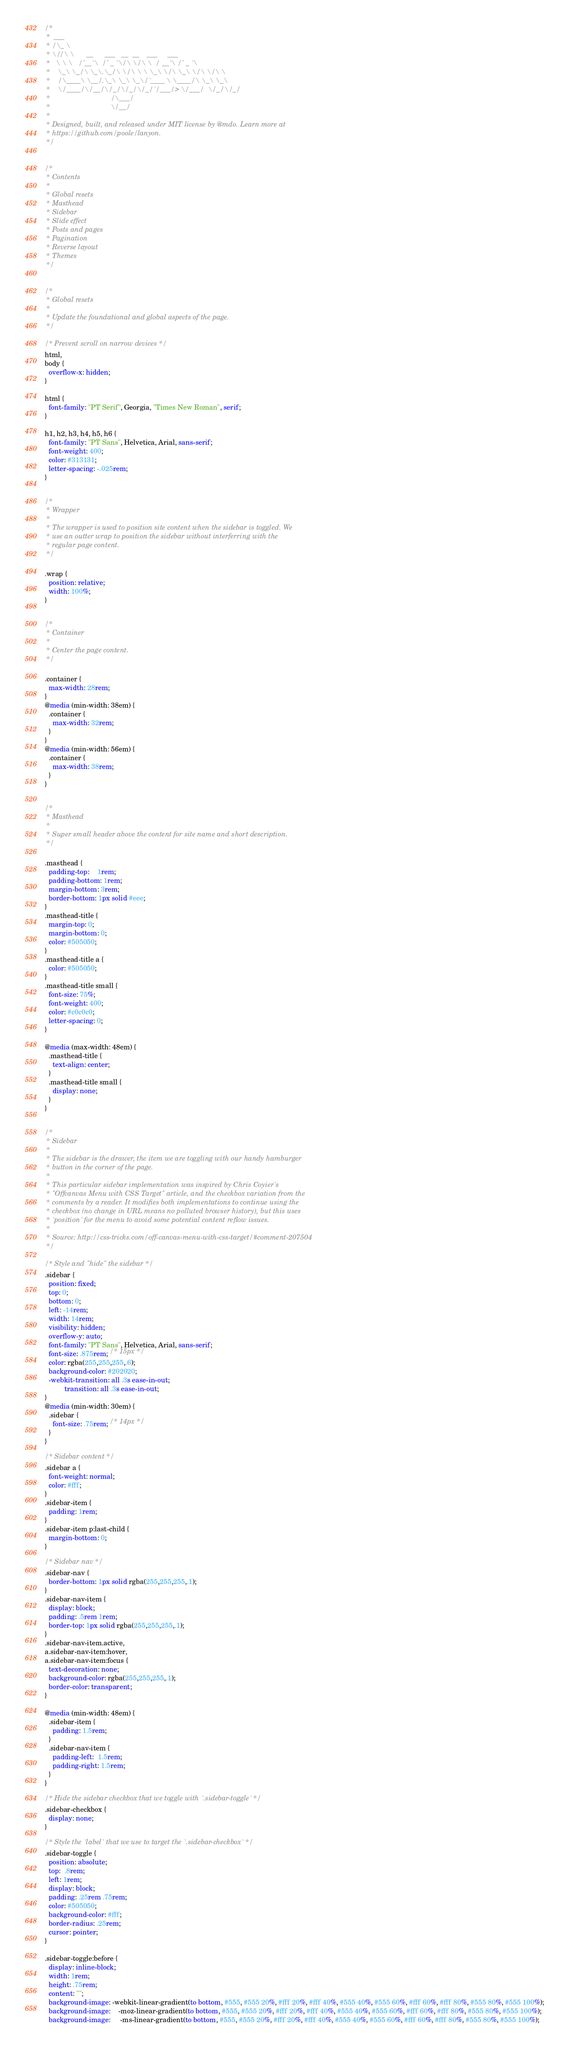Convert code to text. <code><loc_0><loc_0><loc_500><loc_500><_CSS_>/*
 *  ___
 * /\_ \
 * \//\ \      __      ___   __  __    ___     ___
 *   \ \ \   /'__`\  /' _ `\/\ \/\ \  / __`\ /' _ `\
 *    \_\ \_/\ \_\.\_/\ \/\ \ \ \_\ \/\ \_\ \/\ \/\ \
 *    /\____\ \__/.\_\ \_\ \_\/`____ \ \____/\ \_\ \_\
 *    \/____/\/__/\/_/\/_/\/_/`/___/> \/___/  \/_/\/_/
 *                               /\___/
 *                               \/__/
 *
 * Designed, built, and released under MIT license by @mdo. Learn more at
 * https://github.com/poole/lanyon.
 */


/*
 * Contents
 *
 * Global resets
 * Masthead
 * Sidebar
 * Slide effect
 * Posts and pages
 * Pagination
 * Reverse layout
 * Themes
 */


/*
 * Global resets
 *
 * Update the foundational and global aspects of the page.
 */

/* Prevent scroll on narrow devices */
html,
body {
  overflow-x: hidden;
}

html {
  font-family: "PT Serif", Georgia, "Times New Roman", serif;
}

h1, h2, h3, h4, h5, h6 {
  font-family: "PT Sans", Helvetica, Arial, sans-serif;
  font-weight: 400;
  color: #313131;
  letter-spacing: -.025rem;
}


/*
 * Wrapper
 *
 * The wrapper is used to position site content when the sidebar is toggled. We
 * use an outter wrap to position the sidebar without interferring with the
 * regular page content.
 */

.wrap {
  position: relative;
  width: 100%;
}


/*
 * Container
 *
 * Center the page content.
 */

.container {
  max-width: 28rem;
}
@media (min-width: 38em) {
  .container {
    max-width: 32rem;
  }
}
@media (min-width: 56em) {
  .container {
    max-width: 38rem;
  }
}


/*
 * Masthead
 *
 * Super small header above the content for site name and short description.
 */

.masthead {
  padding-top:    1rem;
  padding-bottom: 1rem;
  margin-bottom: 3rem;
  border-bottom: 1px solid #eee;
}
.masthead-title {
  margin-top: 0;
  margin-bottom: 0;
  color: #505050;
}
.masthead-title a {
  color: #505050;
}
.masthead-title small {
  font-size: 75%;
  font-weight: 400;
  color: #c0c0c0;
  letter-spacing: 0;
}

@media (max-width: 48em) {
  .masthead-title {
    text-align: center;
  }
  .masthead-title small {
    display: none;
  }
}


/*
 * Sidebar
 *
 * The sidebar is the drawer, the item we are toggling with our handy hamburger
 * button in the corner of the page.
 *
 * This particular sidebar implementation was inspired by Chris Coyier's
 * "Offcanvas Menu with CSS Target" article, and the checkbox variation from the
 * comments by a reader. It modifies both implementations to continue using the
 * checkbox (no change in URL means no polluted browser history), but this uses
 * `position` for the menu to avoid some potential content reflow issues.
 *
 * Source: http://css-tricks.com/off-canvas-menu-with-css-target/#comment-207504
 */

/* Style and "hide" the sidebar */
.sidebar {
  position: fixed;
  top: 0;
  bottom: 0;
  left: -14rem;
  width: 14rem;
  visibility: hidden;
  overflow-y: auto;
  font-family: "PT Sans", Helvetica, Arial, sans-serif;
  font-size: .875rem; /* 15px */
  color: rgba(255,255,255,.6);
  background-color: #202020;
  -webkit-transition: all .3s ease-in-out;
          transition: all .3s ease-in-out;
}
@media (min-width: 30em) {
  .sidebar {
    font-size: .75rem; /* 14px */
  }
}

/* Sidebar content */
.sidebar a {
  font-weight: normal;
  color: #fff;
}
.sidebar-item {
  padding: 1rem;
}
.sidebar-item p:last-child {
  margin-bottom: 0;
}

/* Sidebar nav */
.sidebar-nav {
  border-bottom: 1px solid rgba(255,255,255,.1);
}
.sidebar-nav-item {
  display: block;
  padding: .5rem 1rem;
  border-top: 1px solid rgba(255,255,255,.1);
}
.sidebar-nav-item.active,
a.sidebar-nav-item:hover,
a.sidebar-nav-item:focus {
  text-decoration: none;
  background-color: rgba(255,255,255,.1);
  border-color: transparent;
}

@media (min-width: 48em) {
  .sidebar-item {
    padding: 1.5rem;
  }
  .sidebar-nav-item {
    padding-left:  1.5rem;
    padding-right: 1.5rem;
  }
}

/* Hide the sidebar checkbox that we toggle with `.sidebar-toggle` */
.sidebar-checkbox {
  display: none;
}

/* Style the `label` that we use to target the `.sidebar-checkbox` */
.sidebar-toggle {
  position: absolute;
  top:  .8rem;
  left: 1rem;
  display: block;
  padding: .25rem .75rem;
  color: #505050;
  background-color: #fff;
  border-radius: .25rem;
  cursor: pointer;
}

.sidebar-toggle:before {
  display: inline-block;
  width: 1rem;
  height: .75rem;
  content: "";
  background-image: -webkit-linear-gradient(to bottom, #555, #555 20%, #fff 20%, #fff 40%, #555 40%, #555 60%, #fff 60%, #fff 80%, #555 80%, #555 100%);
  background-image:    -moz-linear-gradient(to bottom, #555, #555 20%, #fff 20%, #fff 40%, #555 40%, #555 60%, #fff 60%, #fff 80%, #555 80%, #555 100%);
  background-image:     -ms-linear-gradient(to bottom, #555, #555 20%, #fff 20%, #fff 40%, #555 40%, #555 60%, #fff 60%, #fff 80%, #555 80%, #555 100%);</code> 